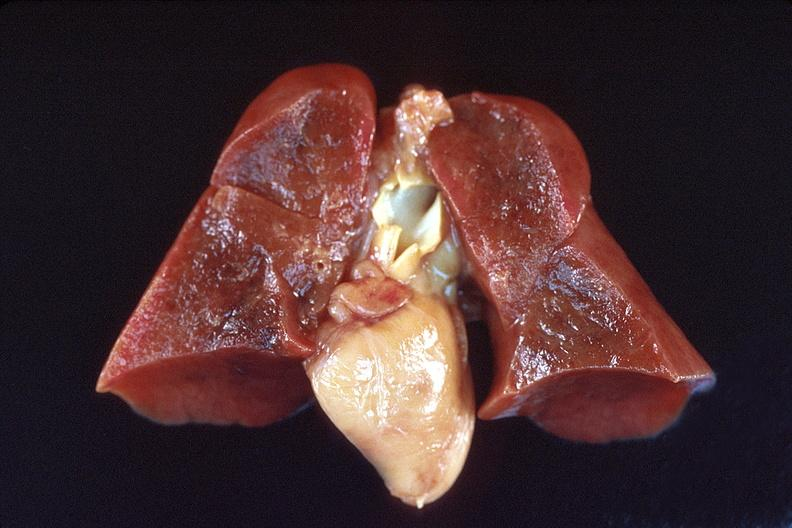what does this image show?
Answer the question using a single word or phrase. Lungs 